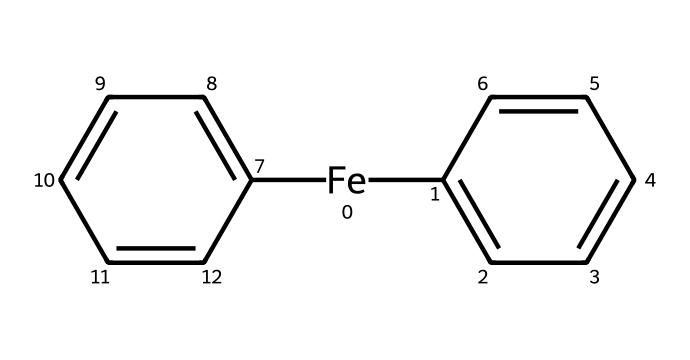What is the central metal atom in this compound? The SMILES representation indicates that iron (Fe) is the central metal atom, as it is explicitly stated at the beginning of the SMILES string.
Answer: iron How many carbon atoms are present in this compound? By analyzing the SMILES structure, there are a total of 12 carbon atoms (6 in each phenyl ring and 1 from the iron carbon bond).
Answer: 12 What type of bonding is present between the metal and carbon in this compound? In organometallic compounds, the bonding between the metal (iron) and carbon occurs via a sigma bond, which is common for carbon-metal interactions in such structures.
Answer: sigma bond How many rings are present in the structure of this compound? The SMILES indicates there are two phenyl (benzene) rings, as shown by the two occurrences of C1=CC=CC=C1 that denote each ring.
Answer: 2 What signifies this compound as an organometallic? The presence of carbon directly bonded to a transition metal (iron) signifies that it is an organometallic compound. This characteristic is essential to defining organometallics.
Answer: carbon-metal bond What is one potential application of this compound in electronics? Organometallic compounds like this can be used in electromagnetic interference shielding due to their conductive properties. Thus, this particular compound could provide effective shielding in electronic devices.
Answer: shielding 